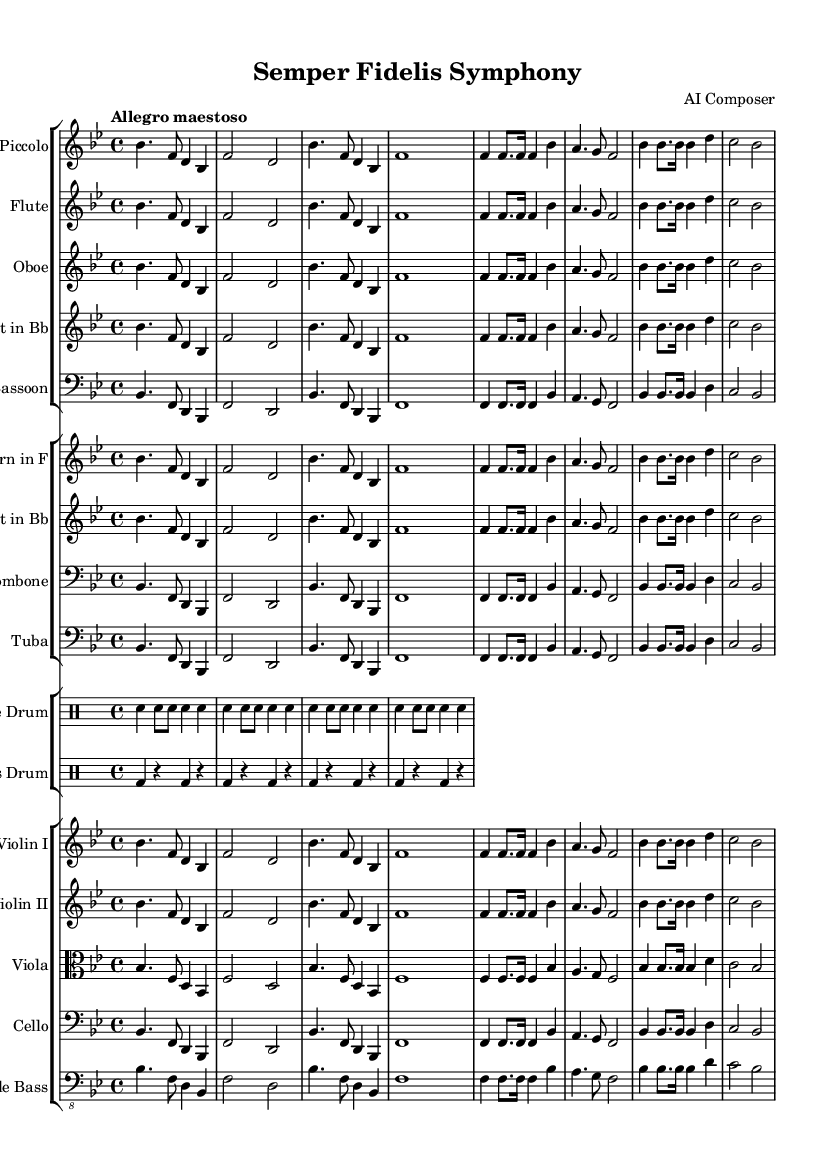What is the key signature of this music? The key signature is B-flat major, which contains two flats (B-flat and E-flat). This can be determined by checking the key signature indicated at the beginning of the sheet music.
Answer: B-flat major What is the time signature used in this piece? The time signature is 4/4, meaning there are four beats per measure and the quarter note receives one beat. This can be seen in the notation at the beginning of the score.
Answer: 4/4 What is the tempo marking for this symphony? The tempo marking is "Allegro maestoso," indicating a lively and majestic speed. The tempo is usually found above the staff at the beginning of the sheet music.
Answer: Allegro maestoso How many total instruments are featured in this symphony? There are sixteen instruments indicated in the score, including woodwinds, brass, percussion, and strings. By counting the individual staves, we can verify this number.
Answer: Sixteen Which instruments are in the brass section of this symphony? The brass section includes the horn, trumpet, trombone, and tuba. These can be identified by looking for their designated staves in the score's brass group.
Answer: Horn, trumpet, trombone, tuba What type of drum is indicated in the percussion section? The percussion section features a snare drum and a bass drum, which are clearly labeled in their respective staves within the drum group in the score.
Answer: Snare drum, bass drum What are the instruments featured in the woodwind section? The woodwind section includes the piccolo, flute, oboe, clarinet, and bassoon. This can be confirmed by checking the staves dedicated to woodwinds at the beginning of the score.
Answer: Piccolo, flute, oboe, clarinet, bassoon 